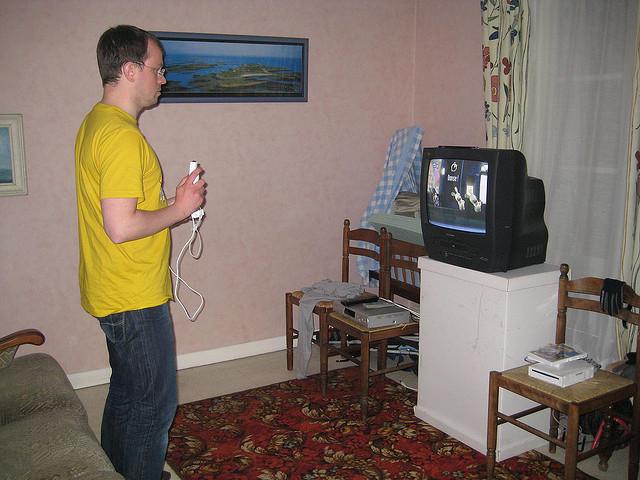Can the man play sitting down?
Be succinct. No. What pattern is the man's rug?
Concise answer only. Floral. What room is this?
Concise answer only. Living room. Is the man playing Nintendo Wii?
Short answer required. Yes. 